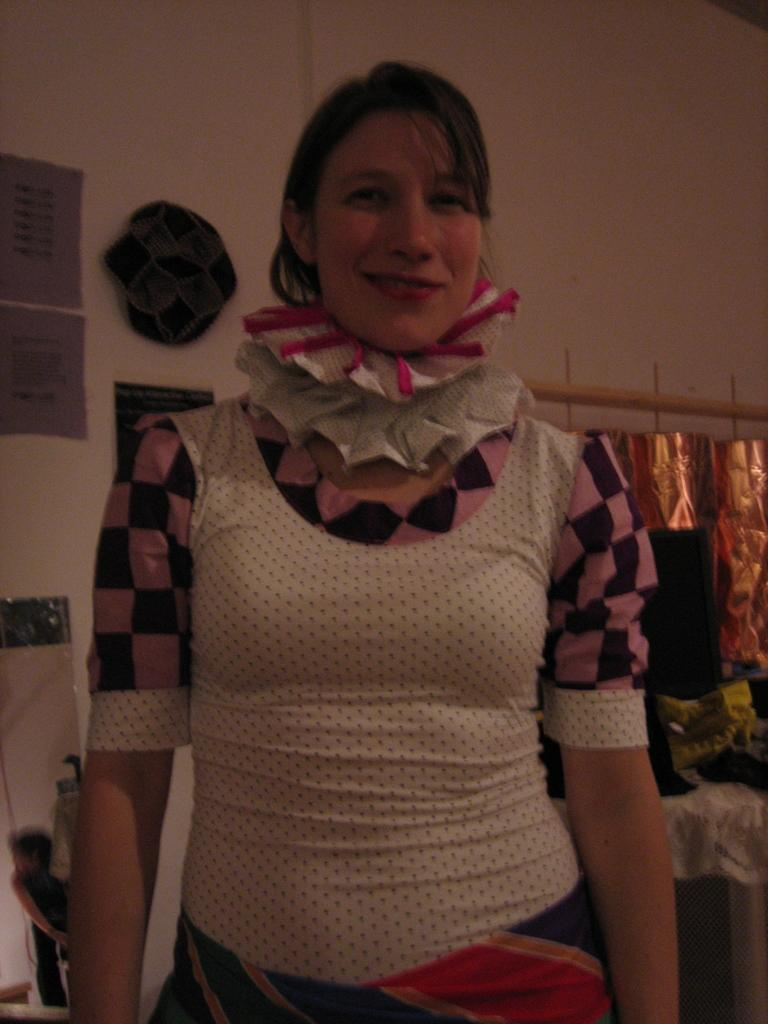Who is present in the image? There is a woman in the image. What is the woman wearing? The woman is wearing a black, pink, and white dress. What is the woman doing in the image? The woman is standing and smiling. What can be seen in the background of the image? There is a wall in the background of the image. What is attached to the wall in the background? There are objects attached to the wall in the background. What type of instrument is the woman playing in the image? The woman is not playing any instrument in the image; she is standing and smiling. 